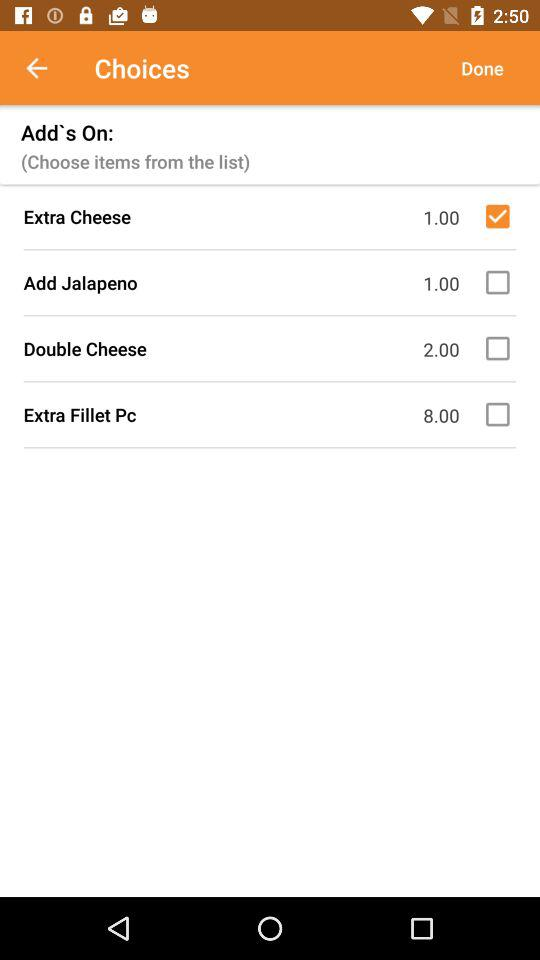Which are the different add-on choices? The different add-on choices are "Extra Cheese", "Add Jalapeno", "Double Cheese" and "Extra Fillet Pc". 